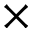Convert formula to latex. <formula><loc_0><loc_0><loc_500><loc_500>\times</formula> 